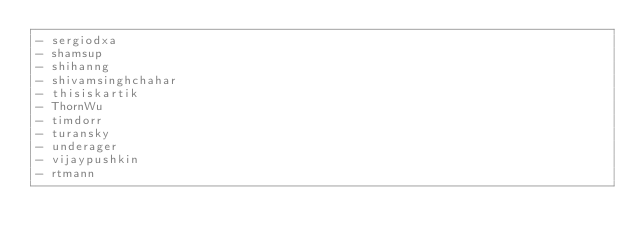<code> <loc_0><loc_0><loc_500><loc_500><_YAML_>- sergiodxa
- shamsup
- shihanng
- shivamsinghchahar
- thisiskartik
- ThornWu
- timdorr
- turansky
- underager
- vijaypushkin
- rtmann
</code> 